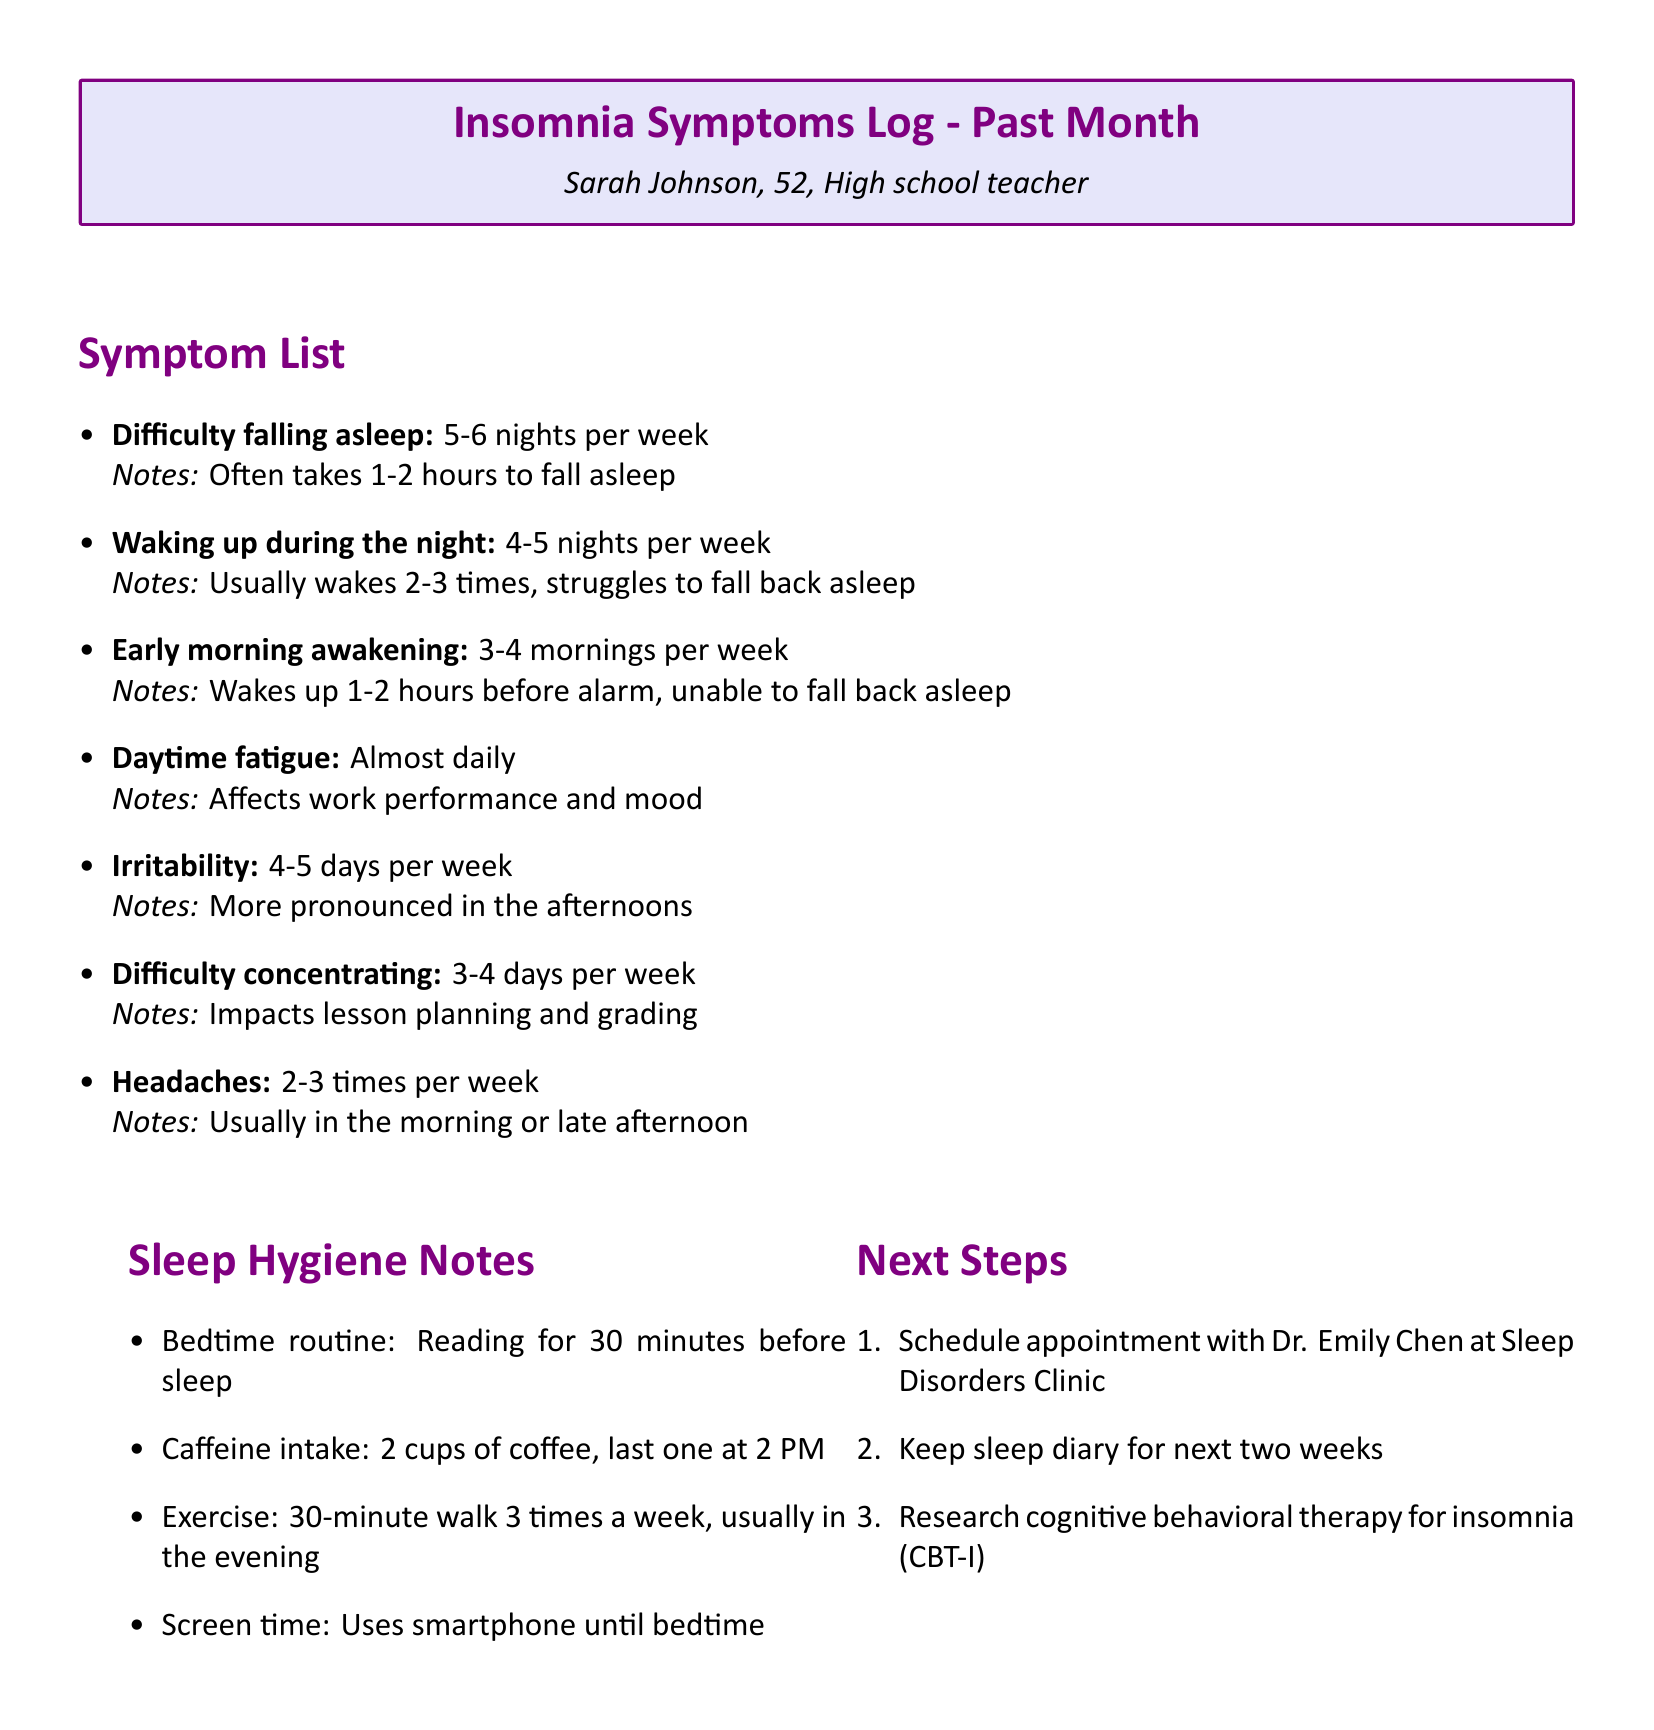What is the name of the person logging symptoms? The name is listed at the top of the document under personal information.
Answer: Sarah Johnson How many nights per week does Sarah experience difficulty falling asleep? This information is provided in the symptom list section of the document.
Answer: 5-6 nights per week What is the frequency of waking up during the night? Frequency for this symptom is detailed in the symptom list within the document.
Answer: 4-5 nights per week How often does Sarah report daytime fatigue? The document specifically states the frequency of this symptom under the symptom list.
Answer: Almost daily What are Sarah's scheduled next steps? The next steps are outlined in a specific section of the document.
Answer: Schedule appointment with Dr. Emily Chen at Sleep Disorders Clinic What does Sarah's bedtime routine involve? This information can be found in the sleep hygiene notes section of the document.
Answer: Reading for 30 minutes before sleep How many cups of coffee does Sarah consume daily? The document mentions this in the sleep hygiene notes section.
Answer: 2 cups Which symptom is more pronounced in the afternoons? This detail is provided in the symptom list for irritability.
Answer: Irritability What therapy is Sarah researching for her insomnia? The document mentions this in the next steps section.
Answer: Cognitive behavioral therapy for insomnia (CBT-I) 